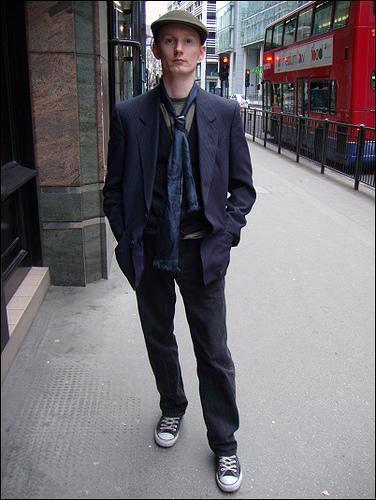How many hands does he have in his pockets?
Give a very brief answer. 2. How many women are in this photo?
Give a very brief answer. 0. How many steps are there?
Give a very brief answer. 1. How many women are posing?
Give a very brief answer. 0. 